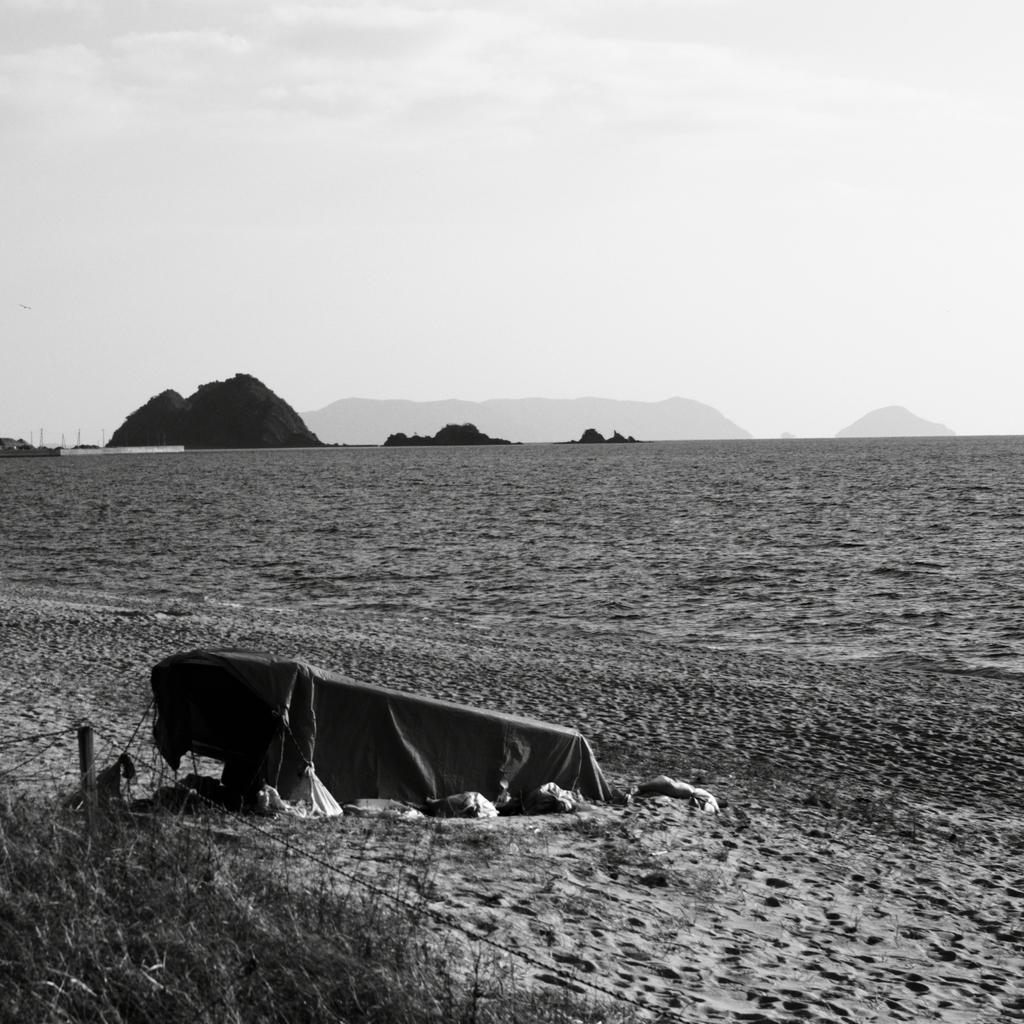In one or two sentences, can you explain what this image depicts? This is a black and white image, in this image there is a land,in the background there are mountains, on the left there is a cloth. 